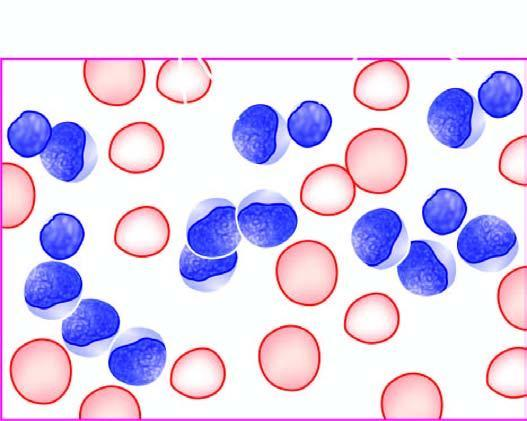re eticulocytes in blood large, with round to convoluted nuclei having high n/c ratio and no cytoplasmic granularity?
Answer the question using a single word or phrase. No 